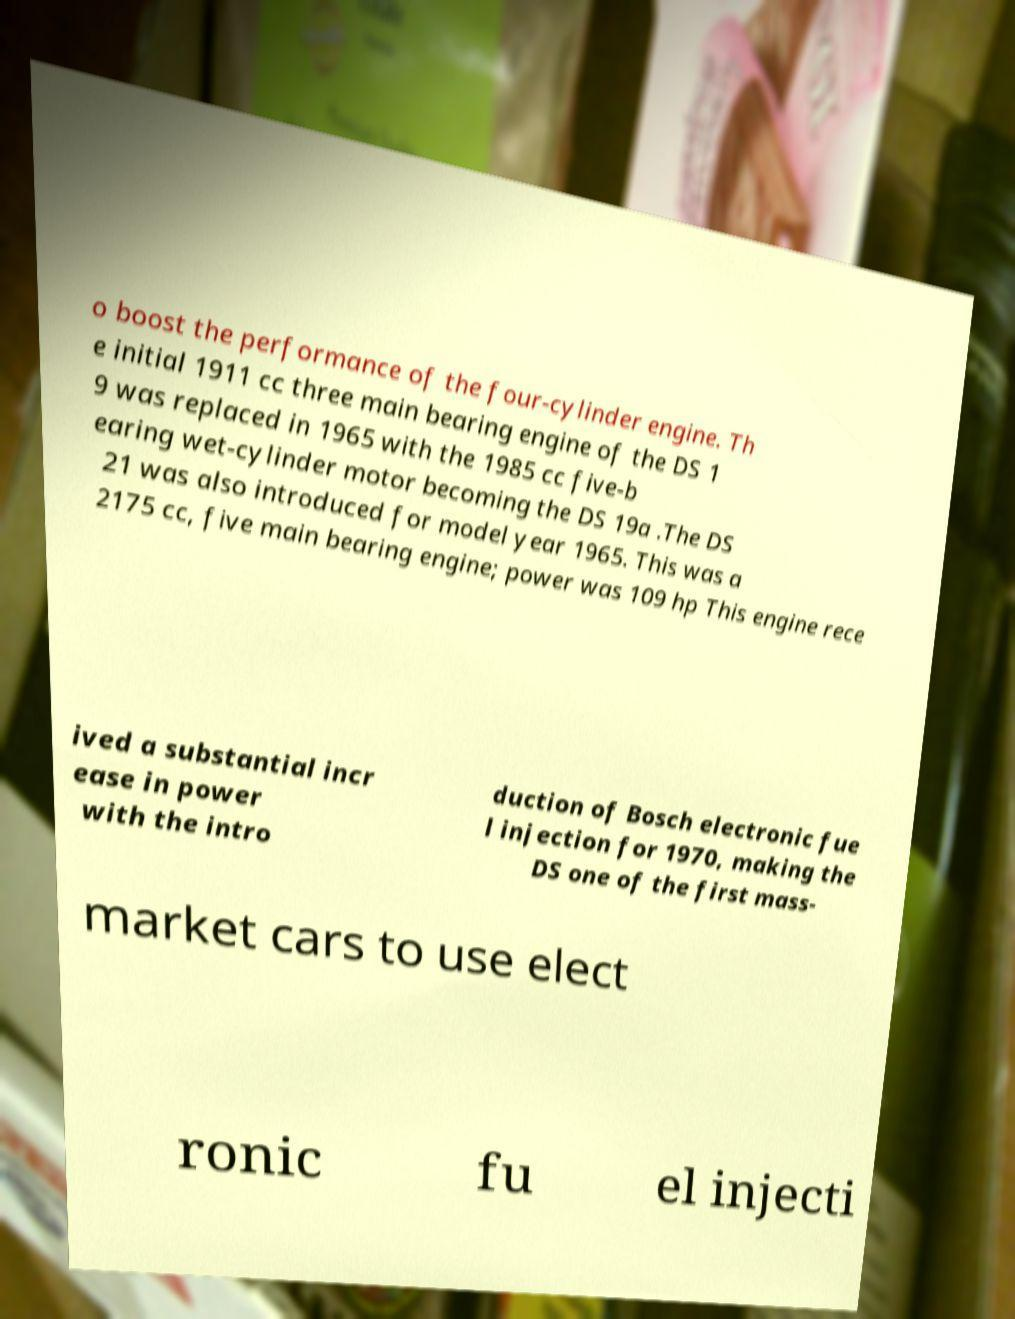Can you accurately transcribe the text from the provided image for me? o boost the performance of the four-cylinder engine. Th e initial 1911 cc three main bearing engine of the DS 1 9 was replaced in 1965 with the 1985 cc five-b earing wet-cylinder motor becoming the DS 19a .The DS 21 was also introduced for model year 1965. This was a 2175 cc, five main bearing engine; power was 109 hp This engine rece ived a substantial incr ease in power with the intro duction of Bosch electronic fue l injection for 1970, making the DS one of the first mass- market cars to use elect ronic fu el injecti 